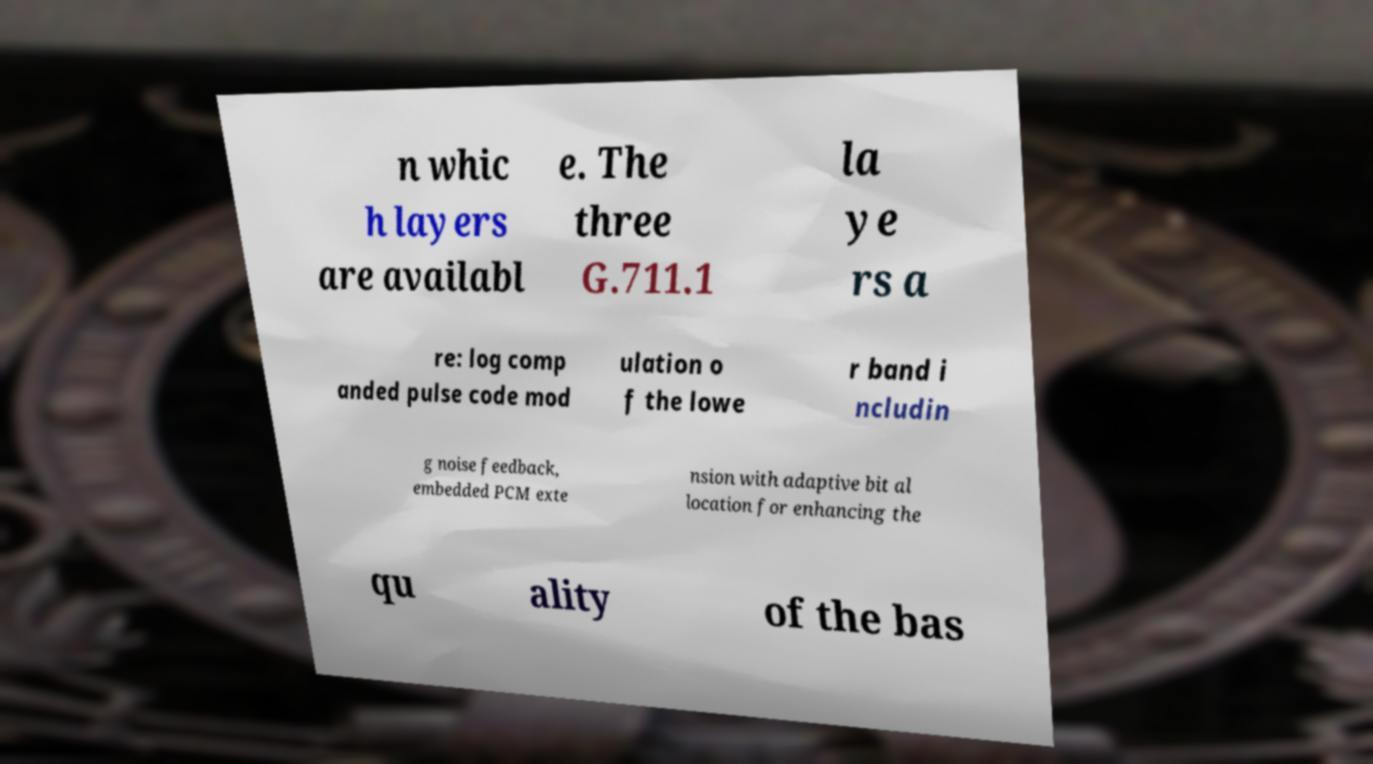For documentation purposes, I need the text within this image transcribed. Could you provide that? n whic h layers are availabl e. The three G.711.1 la ye rs a re: log comp anded pulse code mod ulation o f the lowe r band i ncludin g noise feedback, embedded PCM exte nsion with adaptive bit al location for enhancing the qu ality of the bas 